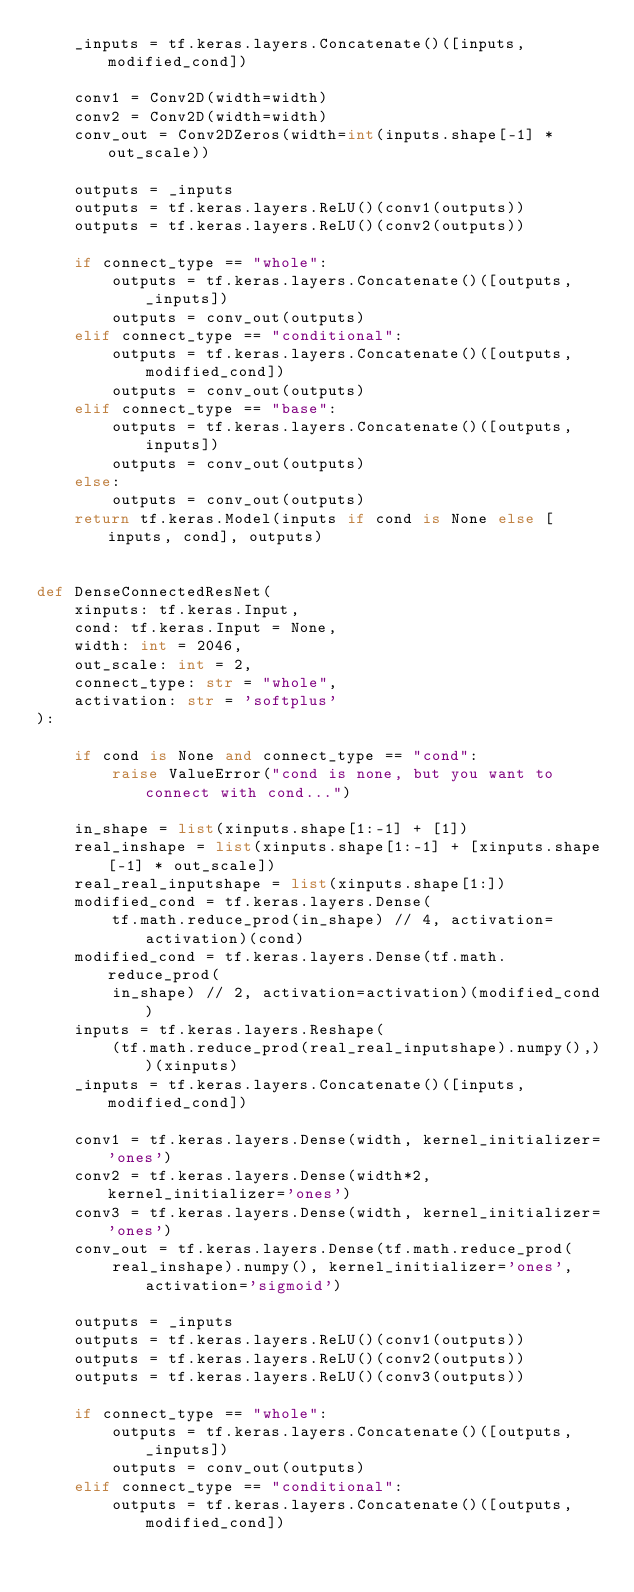<code> <loc_0><loc_0><loc_500><loc_500><_Python_>    _inputs = tf.keras.layers.Concatenate()([inputs, modified_cond])

    conv1 = Conv2D(width=width)
    conv2 = Conv2D(width=width)
    conv_out = Conv2DZeros(width=int(inputs.shape[-1] * out_scale))

    outputs = _inputs
    outputs = tf.keras.layers.ReLU()(conv1(outputs))
    outputs = tf.keras.layers.ReLU()(conv2(outputs))

    if connect_type == "whole":
        outputs = tf.keras.layers.Concatenate()([outputs, _inputs])
        outputs = conv_out(outputs)
    elif connect_type == "conditional":
        outputs = tf.keras.layers.Concatenate()([outputs, modified_cond])
        outputs = conv_out(outputs)
    elif connect_type == "base":
        outputs = tf.keras.layers.Concatenate()([outputs, inputs])
        outputs = conv_out(outputs)
    else:
        outputs = conv_out(outputs)
    return tf.keras.Model(inputs if cond is None else [inputs, cond], outputs)


def DenseConnectedResNet(
    xinputs: tf.keras.Input,
    cond: tf.keras.Input = None,
    width: int = 2046,
    out_scale: int = 2,
    connect_type: str = "whole",
    activation: str = 'softplus'
):

    if cond is None and connect_type == "cond":
        raise ValueError("cond is none, but you want to connect with cond...")

    in_shape = list(xinputs.shape[1:-1] + [1])
    real_inshape = list(xinputs.shape[1:-1] + [xinputs.shape[-1] * out_scale])
    real_real_inputshape = list(xinputs.shape[1:])
    modified_cond = tf.keras.layers.Dense(
        tf.math.reduce_prod(in_shape) // 4, activation=activation)(cond)
    modified_cond = tf.keras.layers.Dense(tf.math.reduce_prod(
        in_shape) // 2, activation=activation)(modified_cond)
    inputs = tf.keras.layers.Reshape(
        (tf.math.reduce_prod(real_real_inputshape).numpy(),))(xinputs)
    _inputs = tf.keras.layers.Concatenate()([inputs, modified_cond])

    conv1 = tf.keras.layers.Dense(width, kernel_initializer='ones')
    conv2 = tf.keras.layers.Dense(width*2, kernel_initializer='ones')
    conv3 = tf.keras.layers.Dense(width, kernel_initializer='ones')
    conv_out = tf.keras.layers.Dense(tf.math.reduce_prod(
        real_inshape).numpy(), kernel_initializer='ones', activation='sigmoid')

    outputs = _inputs
    outputs = tf.keras.layers.ReLU()(conv1(outputs))
    outputs = tf.keras.layers.ReLU()(conv2(outputs))
    outputs = tf.keras.layers.ReLU()(conv3(outputs))

    if connect_type == "whole":
        outputs = tf.keras.layers.Concatenate()([outputs, _inputs])
        outputs = conv_out(outputs)
    elif connect_type == "conditional":
        outputs = tf.keras.layers.Concatenate()([outputs, modified_cond])</code> 